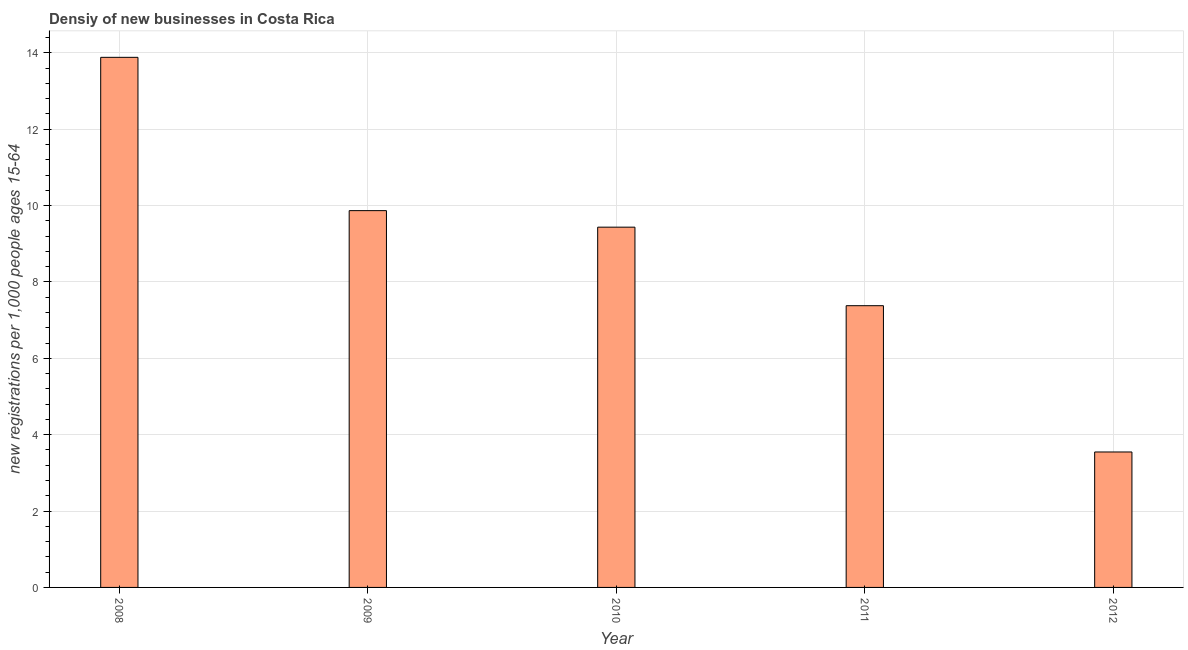Does the graph contain any zero values?
Make the answer very short. No. Does the graph contain grids?
Make the answer very short. Yes. What is the title of the graph?
Your answer should be compact. Densiy of new businesses in Costa Rica. What is the label or title of the X-axis?
Ensure brevity in your answer.  Year. What is the label or title of the Y-axis?
Give a very brief answer. New registrations per 1,0 people ages 15-64. What is the density of new business in 2008?
Ensure brevity in your answer.  13.88. Across all years, what is the maximum density of new business?
Offer a terse response. 13.88. Across all years, what is the minimum density of new business?
Give a very brief answer. 3.55. In which year was the density of new business maximum?
Give a very brief answer. 2008. In which year was the density of new business minimum?
Offer a terse response. 2012. What is the sum of the density of new business?
Your answer should be very brief. 44.11. What is the difference between the density of new business in 2009 and 2011?
Give a very brief answer. 2.49. What is the average density of new business per year?
Your answer should be compact. 8.82. What is the median density of new business?
Keep it short and to the point. 9.44. In how many years, is the density of new business greater than 8.4 ?
Make the answer very short. 3. What is the ratio of the density of new business in 2009 to that in 2010?
Keep it short and to the point. 1.05. What is the difference between the highest and the second highest density of new business?
Ensure brevity in your answer.  4.01. What is the difference between the highest and the lowest density of new business?
Your response must be concise. 10.34. How many years are there in the graph?
Ensure brevity in your answer.  5. What is the difference between two consecutive major ticks on the Y-axis?
Your answer should be very brief. 2. Are the values on the major ticks of Y-axis written in scientific E-notation?
Give a very brief answer. No. What is the new registrations per 1,000 people ages 15-64 of 2008?
Offer a very short reply. 13.88. What is the new registrations per 1,000 people ages 15-64 in 2009?
Ensure brevity in your answer.  9.87. What is the new registrations per 1,000 people ages 15-64 of 2010?
Your answer should be compact. 9.44. What is the new registrations per 1,000 people ages 15-64 in 2011?
Your response must be concise. 7.38. What is the new registrations per 1,000 people ages 15-64 in 2012?
Give a very brief answer. 3.55. What is the difference between the new registrations per 1,000 people ages 15-64 in 2008 and 2009?
Your answer should be very brief. 4.01. What is the difference between the new registrations per 1,000 people ages 15-64 in 2008 and 2010?
Keep it short and to the point. 4.45. What is the difference between the new registrations per 1,000 people ages 15-64 in 2008 and 2011?
Your answer should be very brief. 6.5. What is the difference between the new registrations per 1,000 people ages 15-64 in 2008 and 2012?
Ensure brevity in your answer.  10.34. What is the difference between the new registrations per 1,000 people ages 15-64 in 2009 and 2010?
Ensure brevity in your answer.  0.43. What is the difference between the new registrations per 1,000 people ages 15-64 in 2009 and 2011?
Your answer should be compact. 2.49. What is the difference between the new registrations per 1,000 people ages 15-64 in 2009 and 2012?
Keep it short and to the point. 6.32. What is the difference between the new registrations per 1,000 people ages 15-64 in 2010 and 2011?
Your answer should be very brief. 2.06. What is the difference between the new registrations per 1,000 people ages 15-64 in 2010 and 2012?
Give a very brief answer. 5.89. What is the difference between the new registrations per 1,000 people ages 15-64 in 2011 and 2012?
Your answer should be very brief. 3.83. What is the ratio of the new registrations per 1,000 people ages 15-64 in 2008 to that in 2009?
Your answer should be compact. 1.41. What is the ratio of the new registrations per 1,000 people ages 15-64 in 2008 to that in 2010?
Offer a very short reply. 1.47. What is the ratio of the new registrations per 1,000 people ages 15-64 in 2008 to that in 2011?
Provide a short and direct response. 1.88. What is the ratio of the new registrations per 1,000 people ages 15-64 in 2008 to that in 2012?
Offer a terse response. 3.91. What is the ratio of the new registrations per 1,000 people ages 15-64 in 2009 to that in 2010?
Offer a terse response. 1.05. What is the ratio of the new registrations per 1,000 people ages 15-64 in 2009 to that in 2011?
Offer a terse response. 1.34. What is the ratio of the new registrations per 1,000 people ages 15-64 in 2009 to that in 2012?
Give a very brief answer. 2.78. What is the ratio of the new registrations per 1,000 people ages 15-64 in 2010 to that in 2011?
Ensure brevity in your answer.  1.28. What is the ratio of the new registrations per 1,000 people ages 15-64 in 2010 to that in 2012?
Your answer should be very brief. 2.66. What is the ratio of the new registrations per 1,000 people ages 15-64 in 2011 to that in 2012?
Provide a succinct answer. 2.08. 